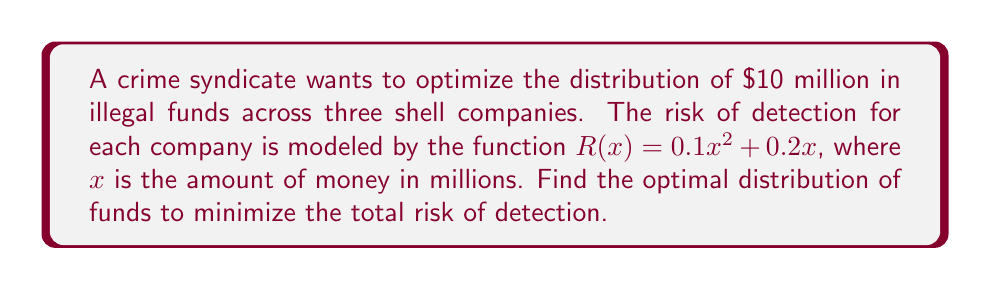Help me with this question. Let's approach this step-by-step:

1) Let $x$, $y$, and $z$ be the amounts (in millions) distributed to each company. We need to minimize the total risk:

   $$R_{total} = (0.1x^2 + 0.2x) + (0.1y^2 + 0.2y) + (0.1z^2 + 0.2z)$$

2) We have two constraints:
   - The total amount must sum to 10: $x + y + z = 10$
   - All amounts must be non-negative: $x, y, z \geq 0$

3) Using the method of Lagrange multipliers, we form the Lagrangian:

   $$L = (0.1x^2 + 0.2x) + (0.1y^2 + 0.2y) + (0.1z^2 + 0.2z) + \lambda(x + y + z - 10)$$

4) We take partial derivatives and set them to zero:

   $$\frac{\partial L}{\partial x} = 0.2x + 0.2 + \lambda = 0$$
   $$\frac{\partial L}{\partial y} = 0.2y + 0.2 + \lambda = 0$$
   $$\frac{\partial L}{\partial z} = 0.2z + 0.2 + \lambda = 0$$
   $$\frac{\partial L}{\partial \lambda} = x + y + z - 10 = 0$$

5) From the first three equations, we can see that $x = y = z$. Let's call this common value $a$.

6) Substituting into the fourth equation:

   $$3a = 10$$
   $$a = \frac{10}{3}$$

7) Therefore, the optimal distribution is to split the money equally among the three companies:

   $$x = y = z = \frac{10}{3} \approx 3.33 \text{ million dollars}$$
Answer: $\frac{10}{3}$ million dollars to each company 